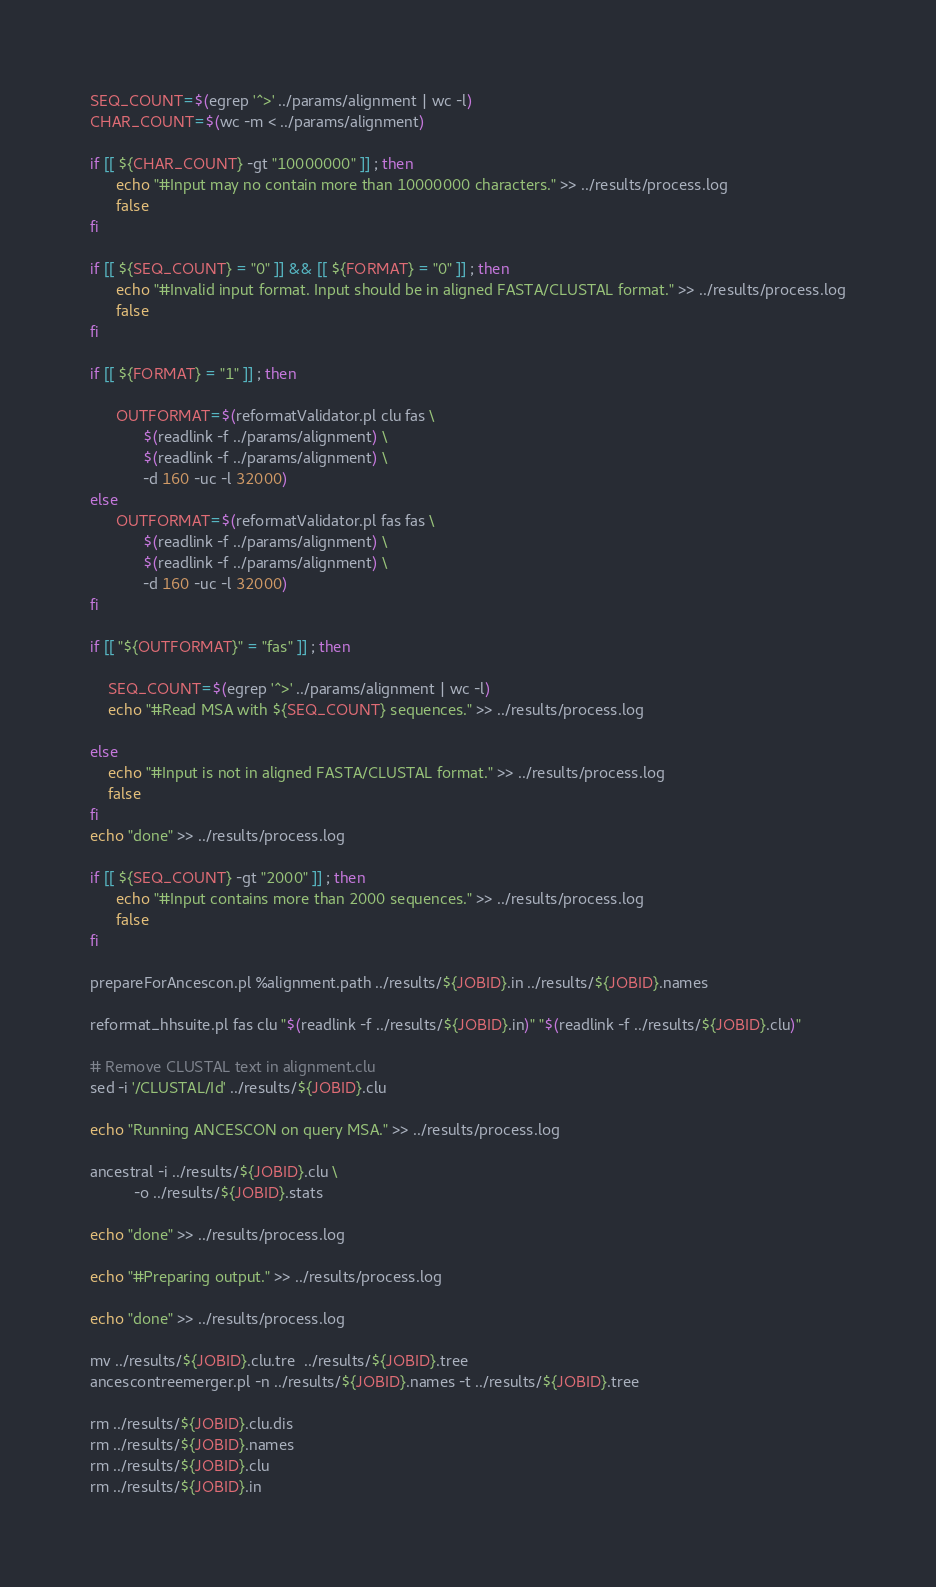Convert code to text. <code><loc_0><loc_0><loc_500><loc_500><_Bash_>SEQ_COUNT=$(egrep '^>' ../params/alignment | wc -l)
CHAR_COUNT=$(wc -m < ../params/alignment)

if [[ ${CHAR_COUNT} -gt "10000000" ]] ; then
      echo "#Input may no contain more than 10000000 characters." >> ../results/process.log
      false
fi

if [[ ${SEQ_COUNT} = "0" ]] && [[ ${FORMAT} = "0" ]] ; then
      echo "#Invalid input format. Input should be in aligned FASTA/CLUSTAL format." >> ../results/process.log
      false
fi

if [[ ${FORMAT} = "1" ]] ; then

      OUTFORMAT=$(reformatValidator.pl clu fas \
	        $(readlink -f ../params/alignment) \
            $(readlink -f ../params/alignment) \
            -d 160 -uc -l 32000)
else
      OUTFORMAT=$(reformatValidator.pl fas fas \
	        $(readlink -f ../params/alignment) \
            $(readlink -f ../params/alignment) \
            -d 160 -uc -l 32000)
fi

if [[ "${OUTFORMAT}" = "fas" ]] ; then

    SEQ_COUNT=$(egrep '^>' ../params/alignment | wc -l)
    echo "#Read MSA with ${SEQ_COUNT} sequences." >> ../results/process.log

else
    echo "#Input is not in aligned FASTA/CLUSTAL format." >> ../results/process.log
    false
fi
echo "done" >> ../results/process.log

if [[ ${SEQ_COUNT} -gt "2000" ]] ; then
      echo "#Input contains more than 2000 sequences." >> ../results/process.log
      false
fi

prepareForAncescon.pl %alignment.path ../results/${JOBID}.in ../results/${JOBID}.names

reformat_hhsuite.pl fas clu "$(readlink -f ../results/${JOBID}.in)" "$(readlink -f ../results/${JOBID}.clu)"

# Remove CLUSTAL text in alignment.clu
sed -i '/CLUSTAL/Id' ../results/${JOBID}.clu

echo "Running ANCESCON on query MSA." >> ../results/process.log

ancestral -i ../results/${JOBID}.clu \
          -o ../results/${JOBID}.stats

echo "done" >> ../results/process.log

echo "#Preparing output." >> ../results/process.log

echo "done" >> ../results/process.log

mv ../results/${JOBID}.clu.tre  ../results/${JOBID}.tree
ancescontreemerger.pl -n ../results/${JOBID}.names -t ../results/${JOBID}.tree

rm ../results/${JOBID}.clu.dis
rm ../results/${JOBID}.names
rm ../results/${JOBID}.clu
rm ../results/${JOBID}.in
</code> 